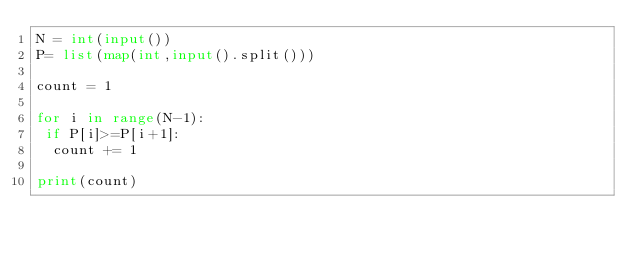<code> <loc_0><loc_0><loc_500><loc_500><_Python_>N = int(input())
P= list(map(int,input().split()))

count = 1

for i in range(N-1):
 if P[i]>=P[i+1]:
  count += 1

print(count)</code> 